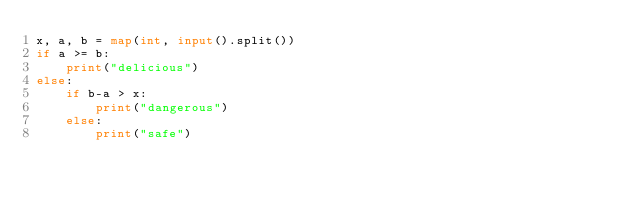Convert code to text. <code><loc_0><loc_0><loc_500><loc_500><_Python_>x, a, b = map(int, input().split())
if a >= b:
    print("delicious")
else:
    if b-a > x:
        print("dangerous")
    else:
        print("safe")</code> 